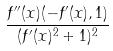<formula> <loc_0><loc_0><loc_500><loc_500>\frac { f ^ { \prime \prime } ( x ) ( - f ^ { \prime } ( x ) , 1 ) } { ( f ^ { \prime } ( x ) ^ { 2 } + 1 ) ^ { 2 } }</formula> 